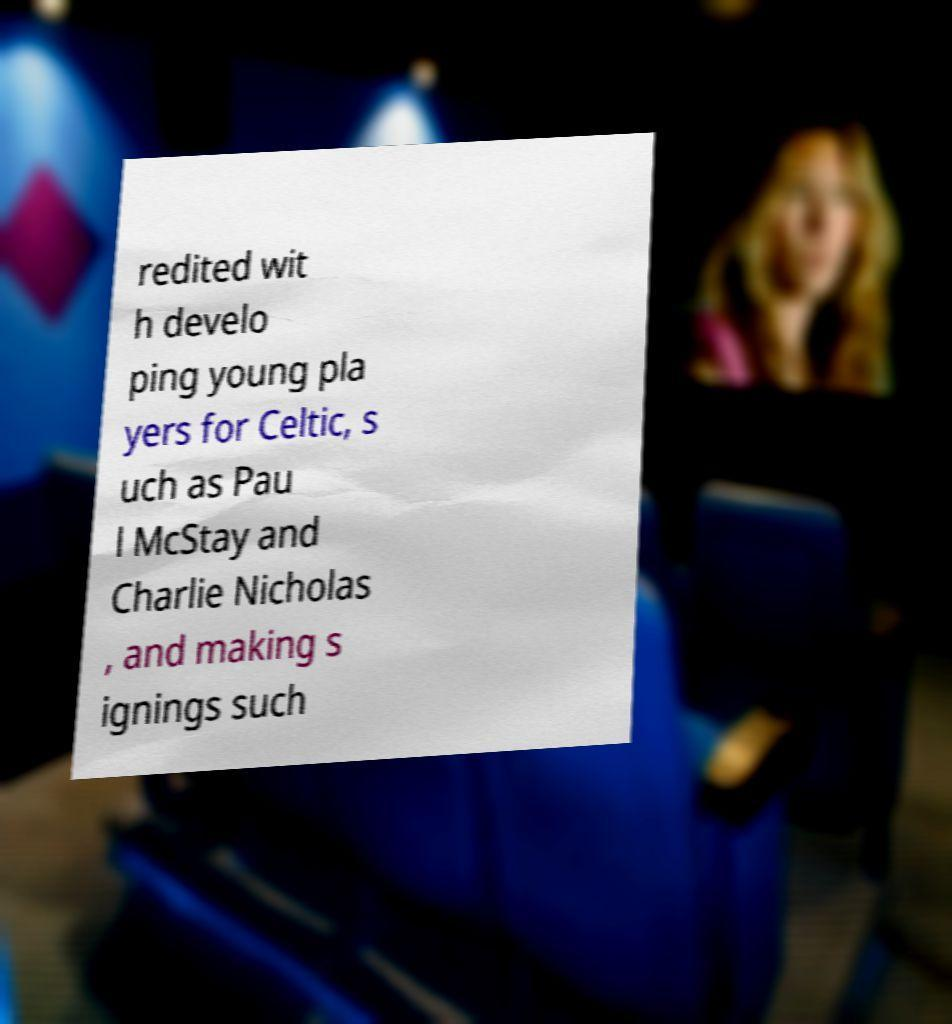Please identify and transcribe the text found in this image. redited wit h develo ping young pla yers for Celtic, s uch as Pau l McStay and Charlie Nicholas , and making s ignings such 